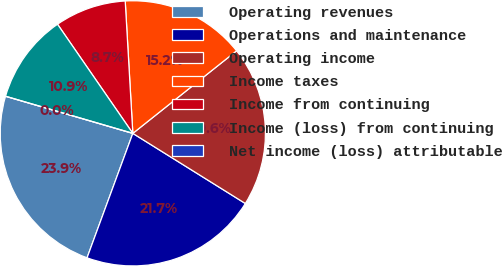Convert chart. <chart><loc_0><loc_0><loc_500><loc_500><pie_chart><fcel>Operating revenues<fcel>Operations and maintenance<fcel>Operating income<fcel>Income taxes<fcel>Income from continuing<fcel>Income (loss) from continuing<fcel>Net income (loss) attributable<nl><fcel>23.91%<fcel>21.74%<fcel>19.57%<fcel>15.22%<fcel>8.7%<fcel>10.87%<fcel>0.0%<nl></chart> 